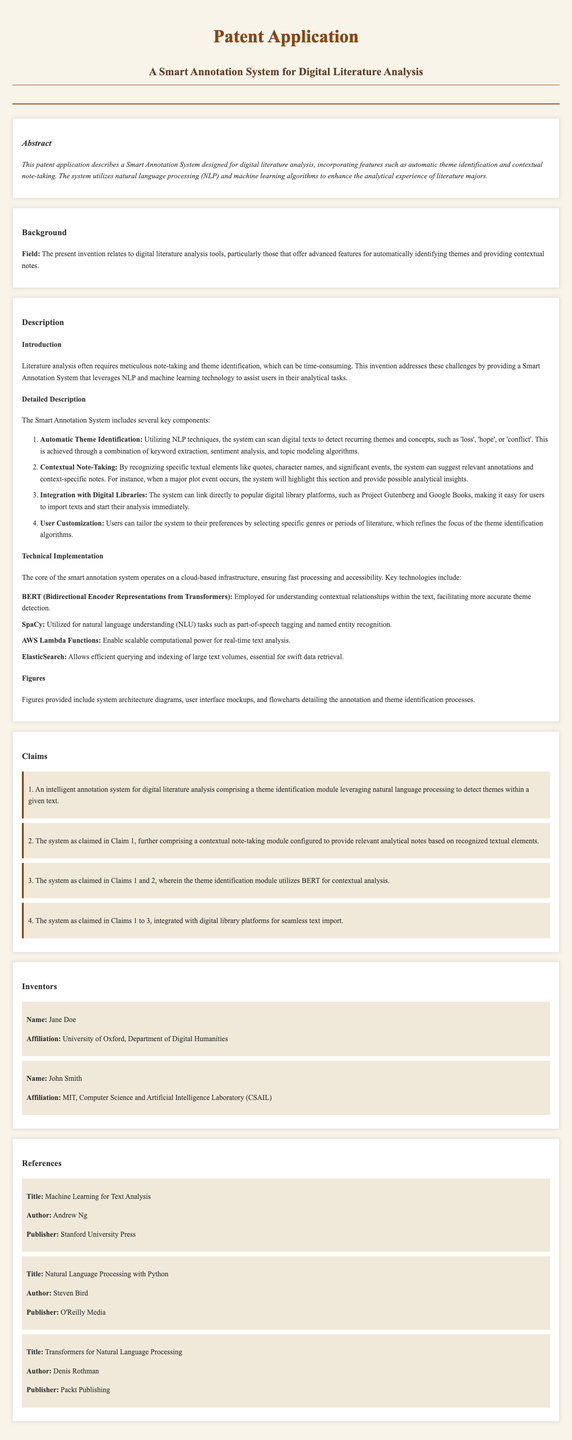What is the title of the patent application? The title of the patent application is stated at the beginning of the document.
Answer: Smart Annotation System for Digital Literature Analysis Who are the inventors listed in the document? The inventors are provided in the respective section of the document.
Answer: Jane Doe and John Smith What technology is used for understanding contextual relationships? The document mentions specific technologies used for various functionalities.
Answer: BERT What does the Smart Annotation System utilize to assist users? The document outlines the main purpose of the system in the description section.
Answer: Natural language processing and machine learning How many claims are included in the patent application? The claims section details the number of claims made in the patent application.
Answer: Four What is one key feature of the Smart Annotation System? The features of the system are highlighted in the detailed description section.
Answer: Automatic theme identification Which platforms does the system integrate with? The document specifies the integration capabilities of the system in its functionality description.
Answer: Digital library platforms What does the system provide based on recognized textual elements? The description section discusses the functionalities related to annotations.
Answer: Contextual notes What type of analysis do the theme identification algorithms conduct? The background section explains the functionality of the system pertaining to analytical tasks.
Answer: Theme identification 